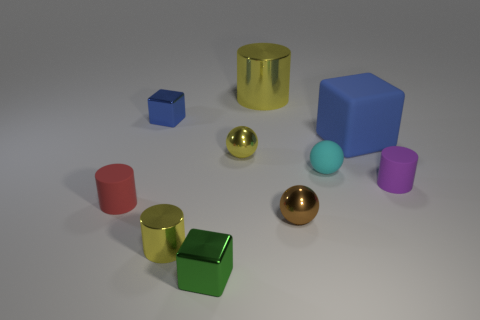Are there fewer red objects that are behind the purple cylinder than cylinders that are in front of the large yellow metallic thing? Yes, upon inspecting the image, it appears there is one red cylinder behind the purple cylinder, while there are two cylinders, a green one and a yellow one, placed in front of the large yellow metallic object. Therefore, there are indeed fewer red objects behind the purple cylinder compared to the number of cylinders in front of the large yellow metallic item. 